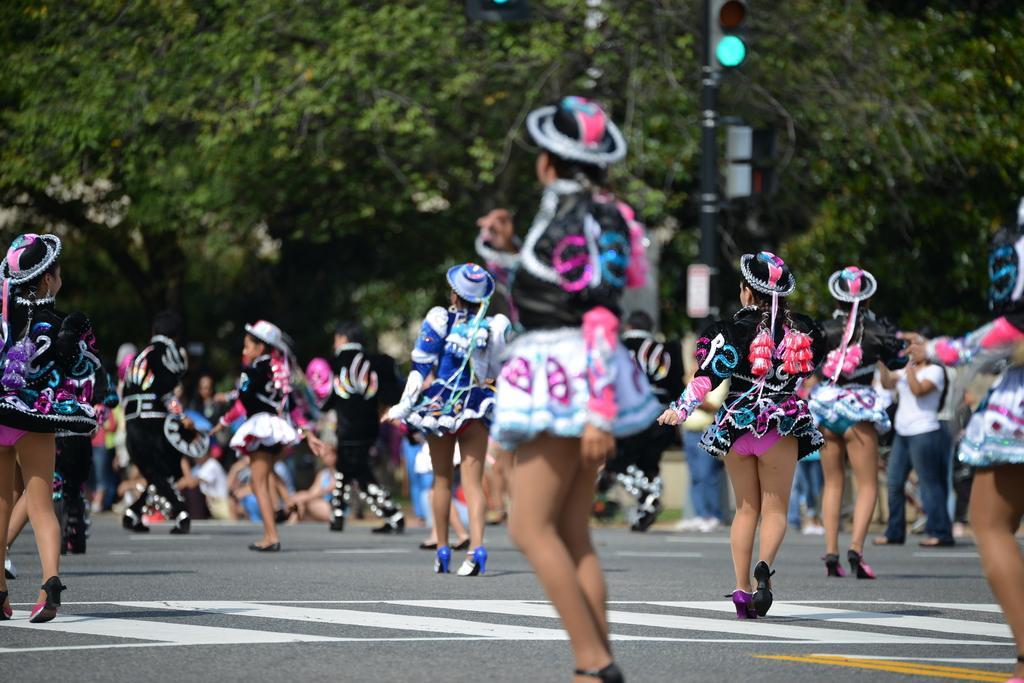Please provide a concise description of this image. In this image I can see few persons wearing black, white, blue and pink colored dresses are standing on the road. In the background I can see the black colored pole, a traffic signal to the pole and few trees which are green in color. 